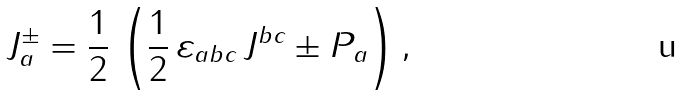Convert formula to latex. <formula><loc_0><loc_0><loc_500><loc_500>J _ { a } ^ { \pm } = \frac { 1 } { 2 } \, \left ( \frac { 1 } { 2 } \, \varepsilon _ { a b c } \, J ^ { b c } \pm P _ { a } \right ) ,</formula> 